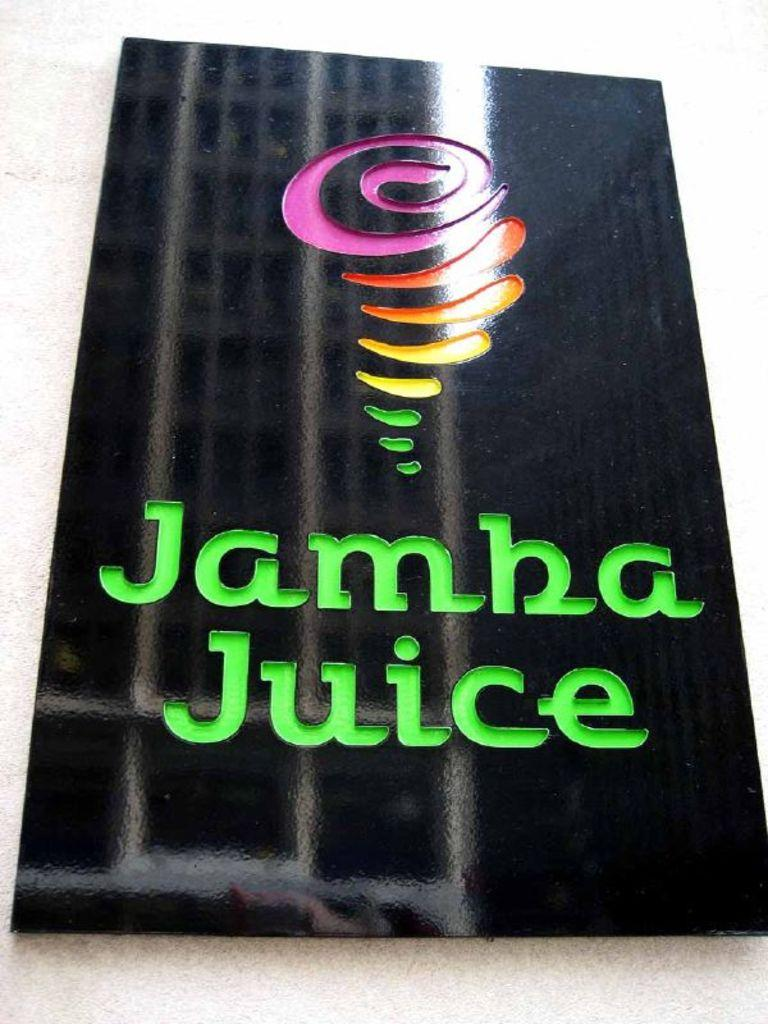<image>
Share a concise interpretation of the image provided. A black Jamba Juice sign with a rainbow tornado logo  on the cement wall. 